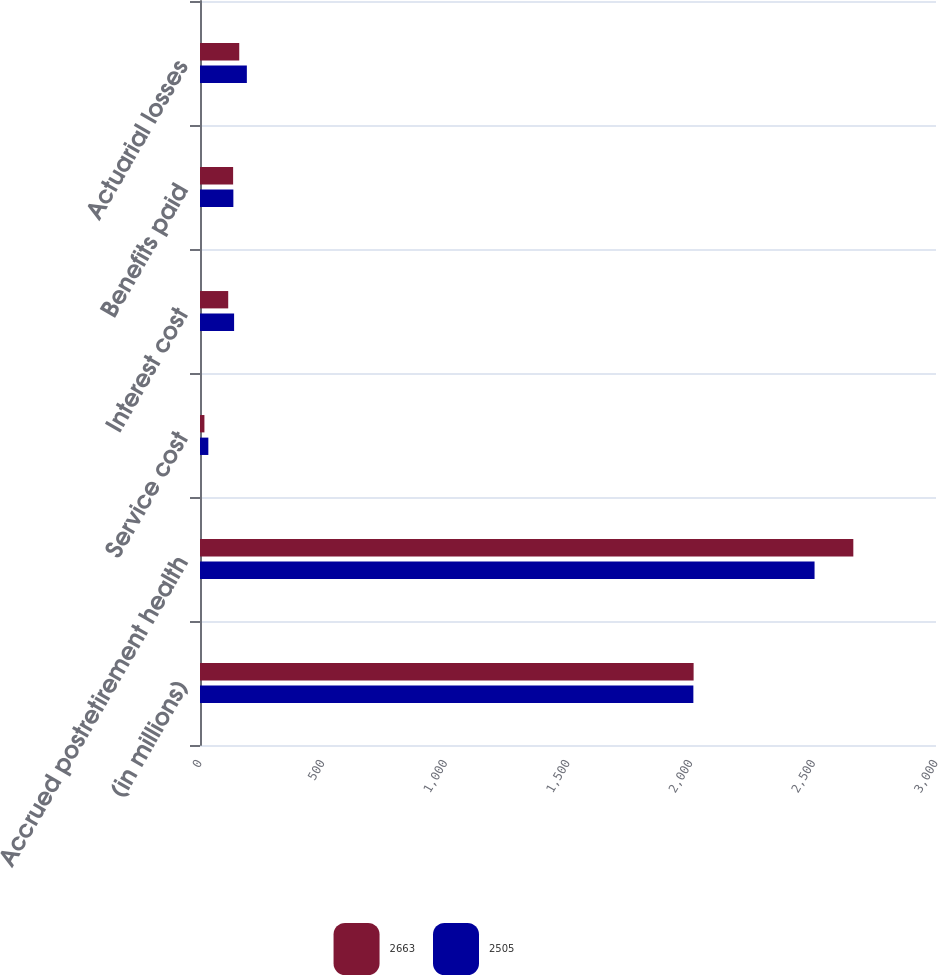<chart> <loc_0><loc_0><loc_500><loc_500><stacked_bar_chart><ecel><fcel>(in millions)<fcel>Accrued postretirement health<fcel>Service cost<fcel>Interest cost<fcel>Benefits paid<fcel>Actuarial losses<nl><fcel>2663<fcel>2012<fcel>2663<fcel>18<fcel>115<fcel>135<fcel>160<nl><fcel>2505<fcel>2011<fcel>2505<fcel>34<fcel>139<fcel>136<fcel>191<nl></chart> 